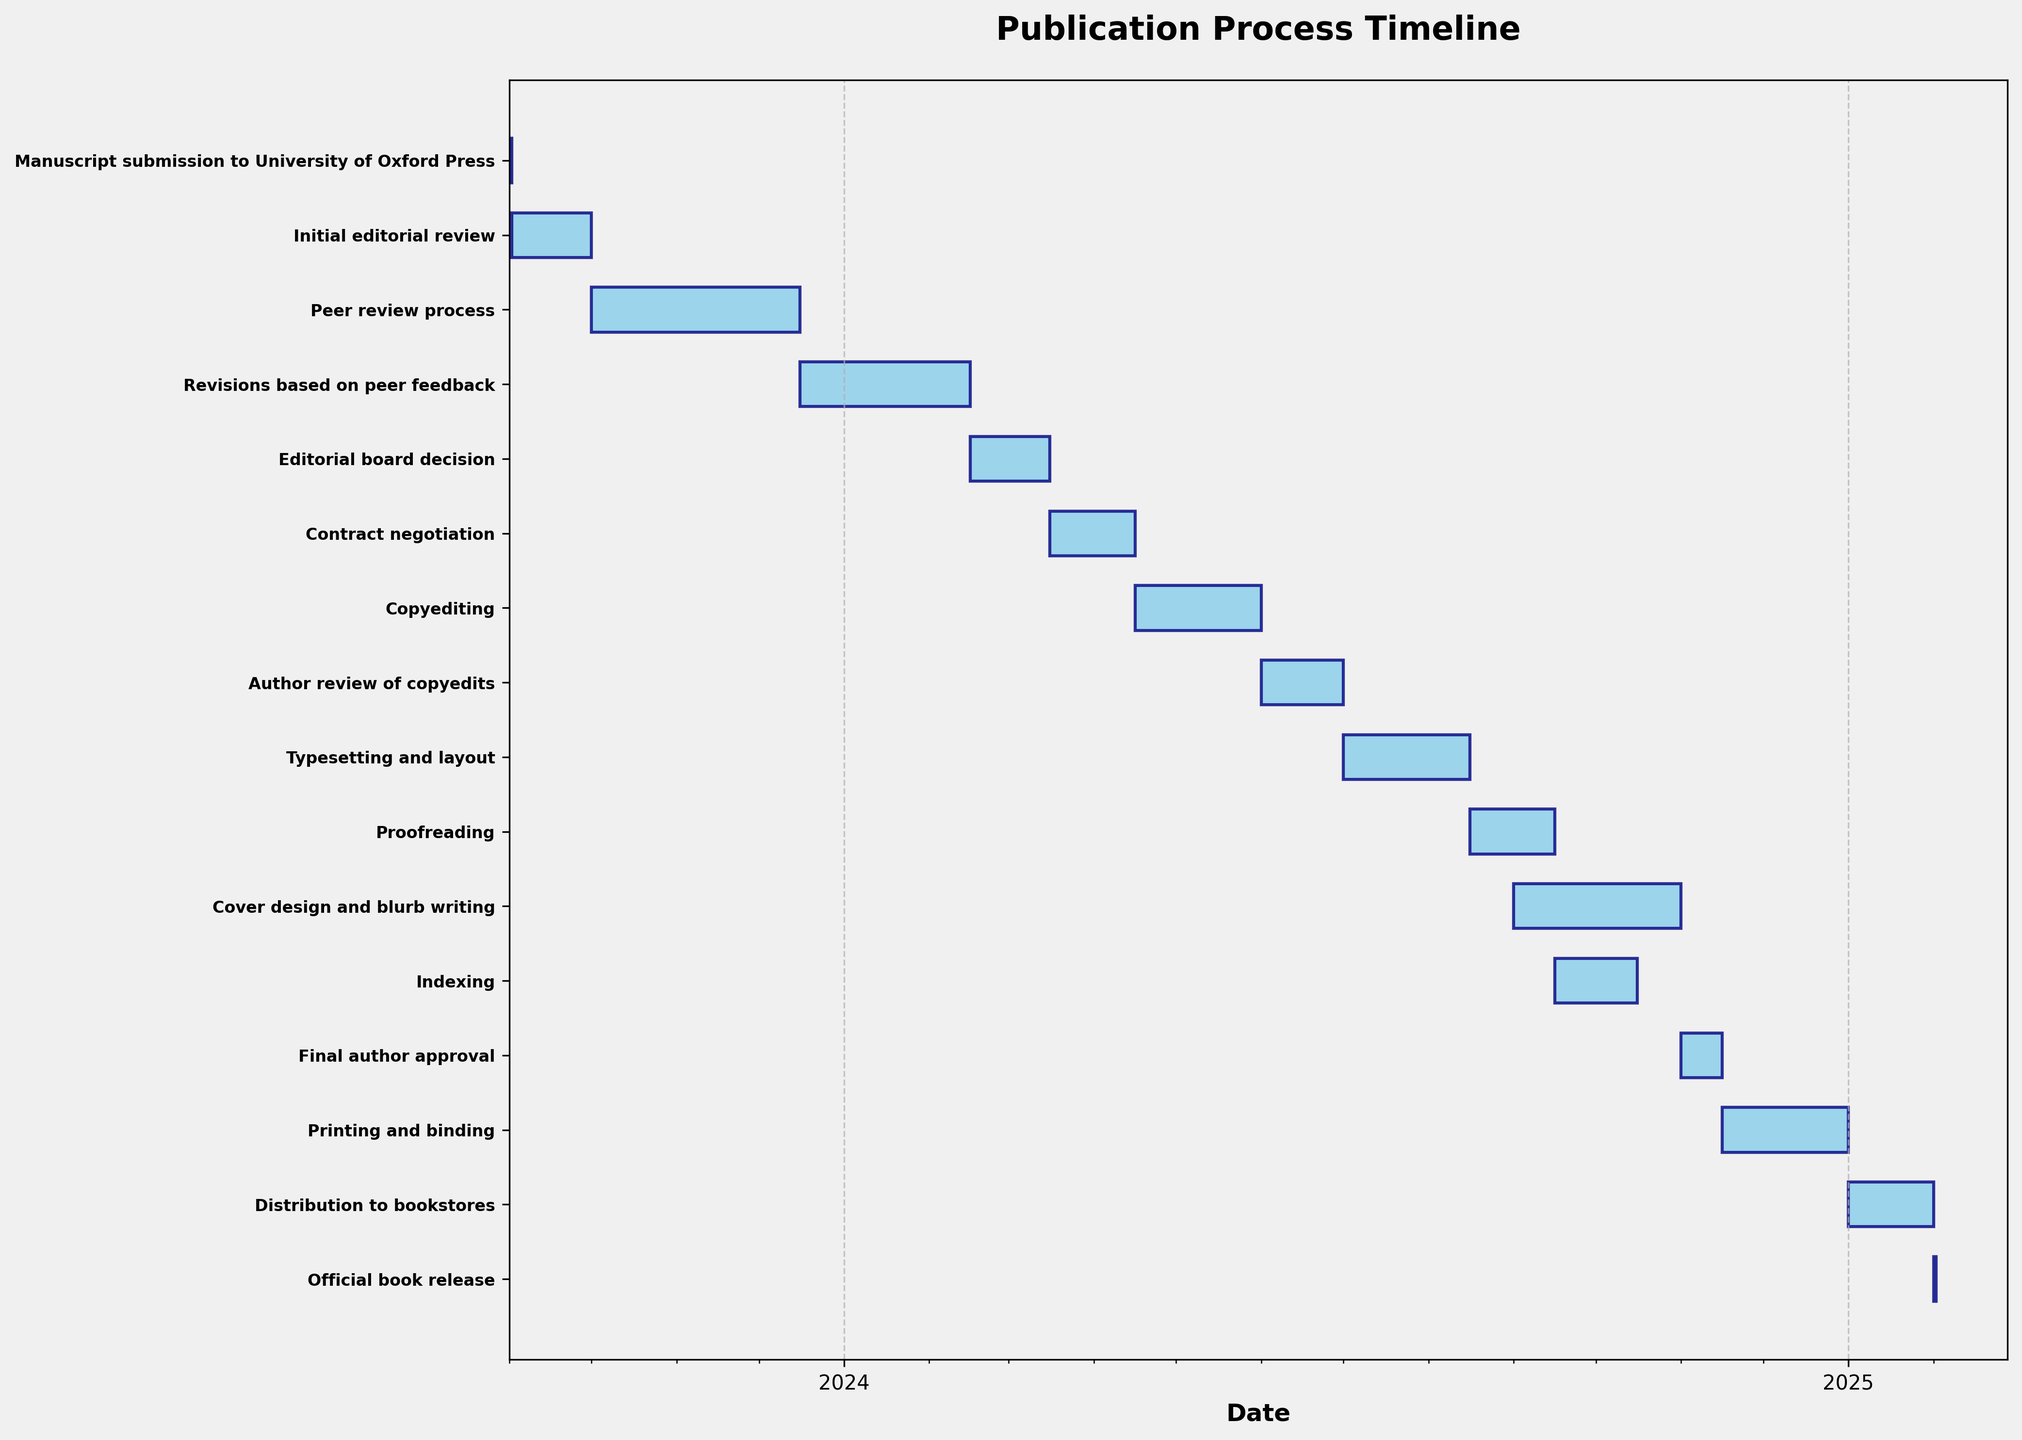What is the total duration of the peer review process? To find the total duration of the peer review process, look at the "Peer review process" bar on the Gantt chart. The start date is 2023-10-01 and the end date is 2023-12-15. The duration is from October 1 to December 15, which is 76 days.
Answer: 76 days Which task spans the longest duration? To determine which task spans the longest duration, look at the length of all the bars on the Gantt chart. "Copyediting" spans from 2024-04-16 to 2024-05-31, which is 46 days, while "Printing and binding" spans from 2024-11-16 to 2024-12-31, which is 46 days. Both tasks are the longest.
Answer: "Copyediting" and "Printing and binding" Which task occurs immediately after "Revisions based on peer feedback"? To identify the task that occurs immediately after "Revisions based on peer feedback," locate this task on the Gantt chart and see what follows. The next task is "Editorial board decision" starting on 2024-02-16.
Answer: "Editorial board decision" How many tasks are involved in the publication process? Count the number of bars (tasks) displayed on the Gantt chart. Each row represents a task. There are 15 tasks listed from "Manuscript submission to University of Oxford Press" to "Official book release".
Answer: 15 tasks What tasks are overlapping in September 2024? Check the Gantt chart bars that appear in September 2024. "Proofreading" (2024-08-16 to 2024-09-15), "Indexing" (2024-09-16 to 2024-10-15), and "Cover design and blurb writing" (2024-09-01 to 2024-10-31) overlap in September 2024.
Answer: "Proofreading", "Indexing", and "Cover design and blurb writing" Which task has the shortest duration? Look for the shortest bar on the Gantt chart. The "Manuscript submission to University of Oxford Press" task has the shortest duration, starting and ending on the same date (2023-09-01), so it lasts only 1 day.
Answer: "Manuscript submission to University of Oxford Press" During what months does the "Contract negotiation" task take place? Locate the "Contract negotiation" task on the Gantt chart. It spans from 2024-03-16 to 2024-04-15, covering the months of March and April 2024.
Answer: March and April 2024 When is the official book release scheduled? Find the "Official book release" task on the Gantt chart. It is scheduled for 2025-02-01.
Answer: 2025-02-01 How long does the "Author review of copyedits" task last? Check the duration of the "Author review of copyedits" bar on the Gantt chart. It starts on 2024-06-01 and ends on 2024-06-30, lasting 30 days.
Answer: 30 days 